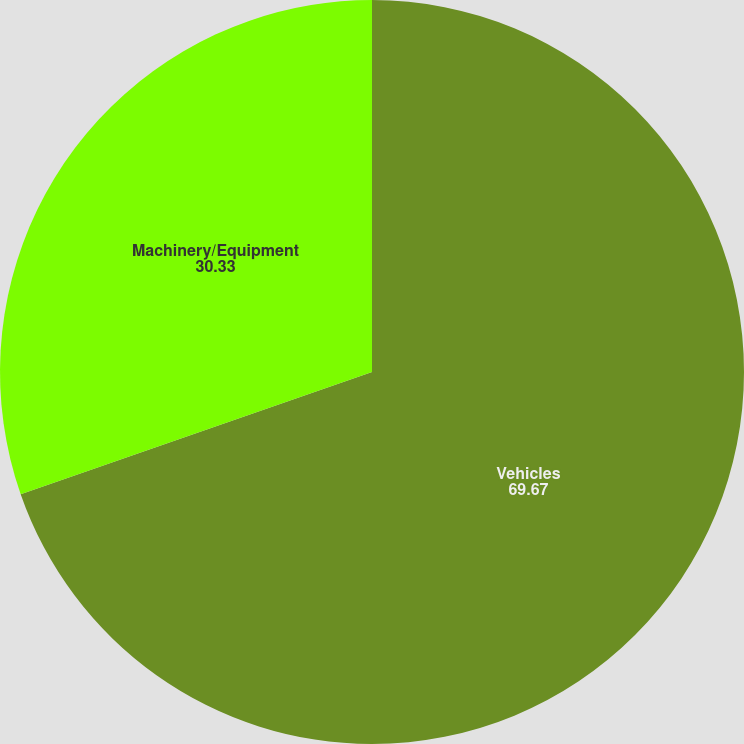Convert chart. <chart><loc_0><loc_0><loc_500><loc_500><pie_chart><fcel>Vehicles<fcel>Machinery/Equipment<nl><fcel>69.67%<fcel>30.33%<nl></chart> 